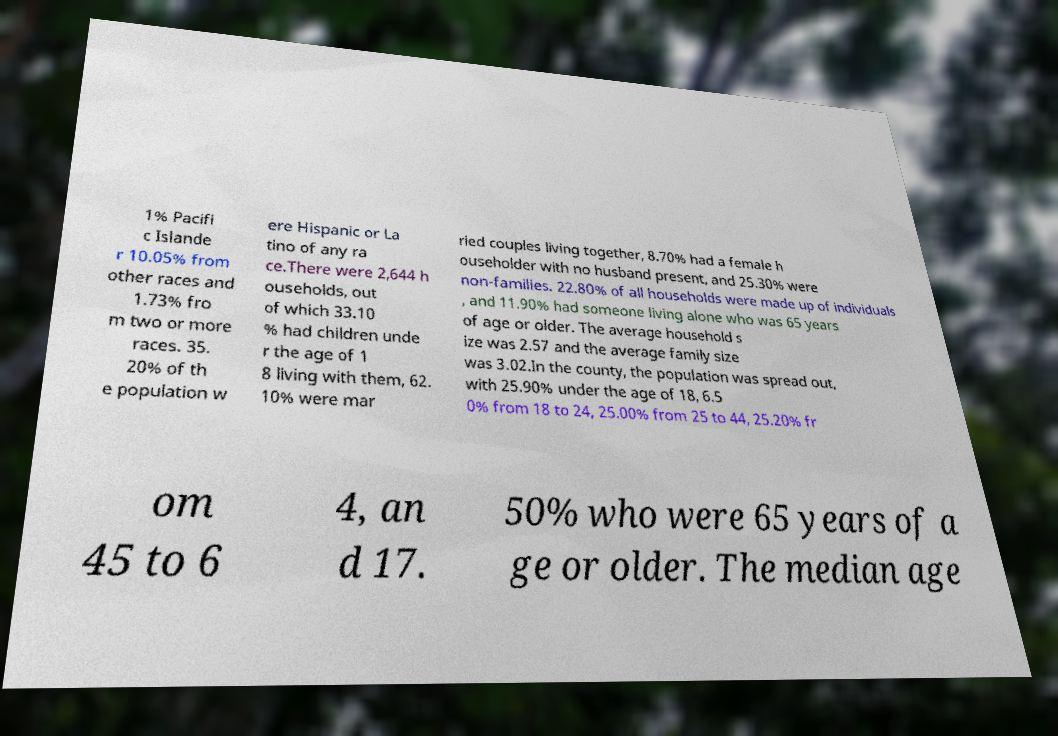What messages or text are displayed in this image? I need them in a readable, typed format. 1% Pacifi c Islande r 10.05% from other races and 1.73% fro m two or more races. 35. 20% of th e population w ere Hispanic or La tino of any ra ce.There were 2,644 h ouseholds, out of which 33.10 % had children unde r the age of 1 8 living with them, 62. 10% were mar ried couples living together, 8.70% had a female h ouseholder with no husband present, and 25.30% were non-families. 22.80% of all households were made up of individuals , and 11.90% had someone living alone who was 65 years of age or older. The average household s ize was 2.57 and the average family size was 3.02.In the county, the population was spread out, with 25.90% under the age of 18, 6.5 0% from 18 to 24, 25.00% from 25 to 44, 25.20% fr om 45 to 6 4, an d 17. 50% who were 65 years of a ge or older. The median age 